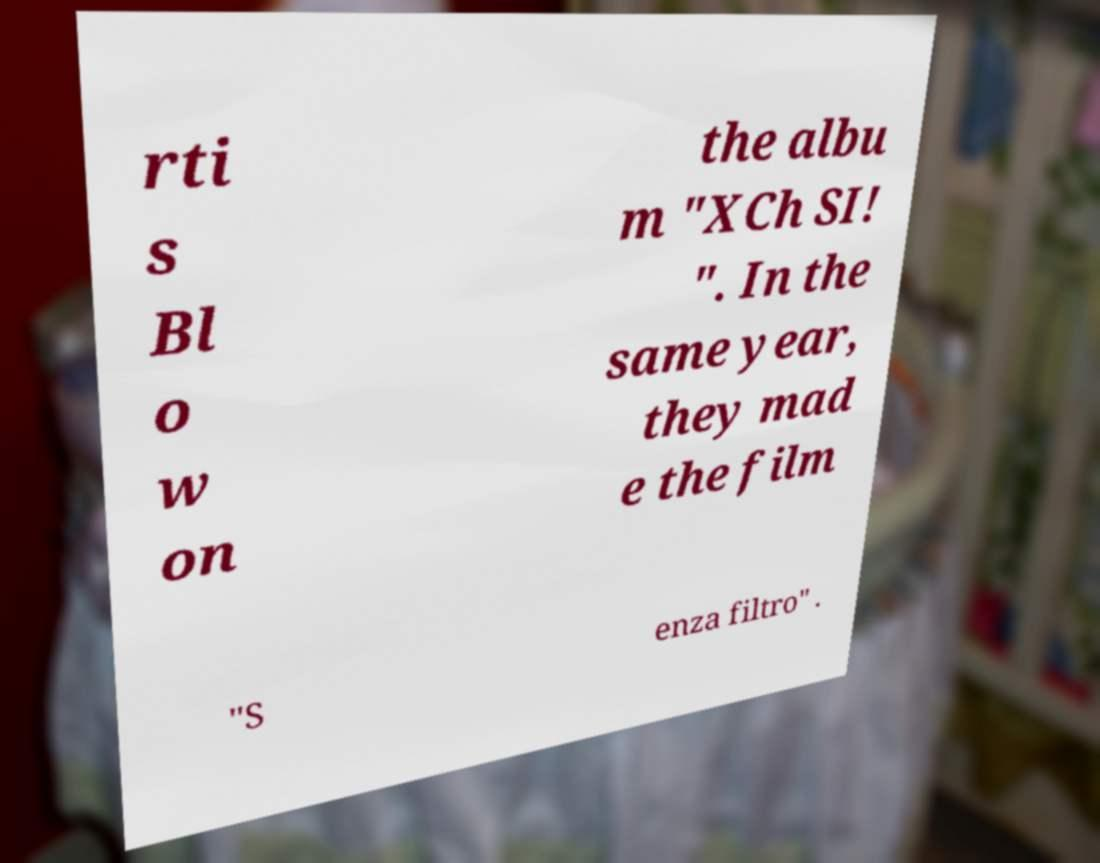Could you extract and type out the text from this image? rti s Bl o w on the albu m "XCh SI! ". In the same year, they mad e the film "S enza filtro" . 